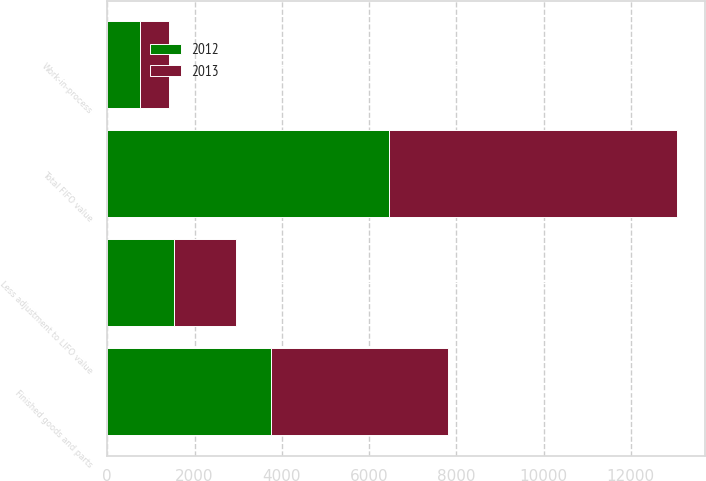Convert chart. <chart><loc_0><loc_0><loc_500><loc_500><stacked_bar_chart><ecel><fcel>Work-in-process<fcel>Finished goods and parts<fcel>Total FIFO value<fcel>Less adjustment to LIFO value<nl><fcel>2012<fcel>753<fcel>3757<fcel>6464<fcel>1529<nl><fcel>2013<fcel>652<fcel>4065<fcel>6591<fcel>1421<nl></chart> 